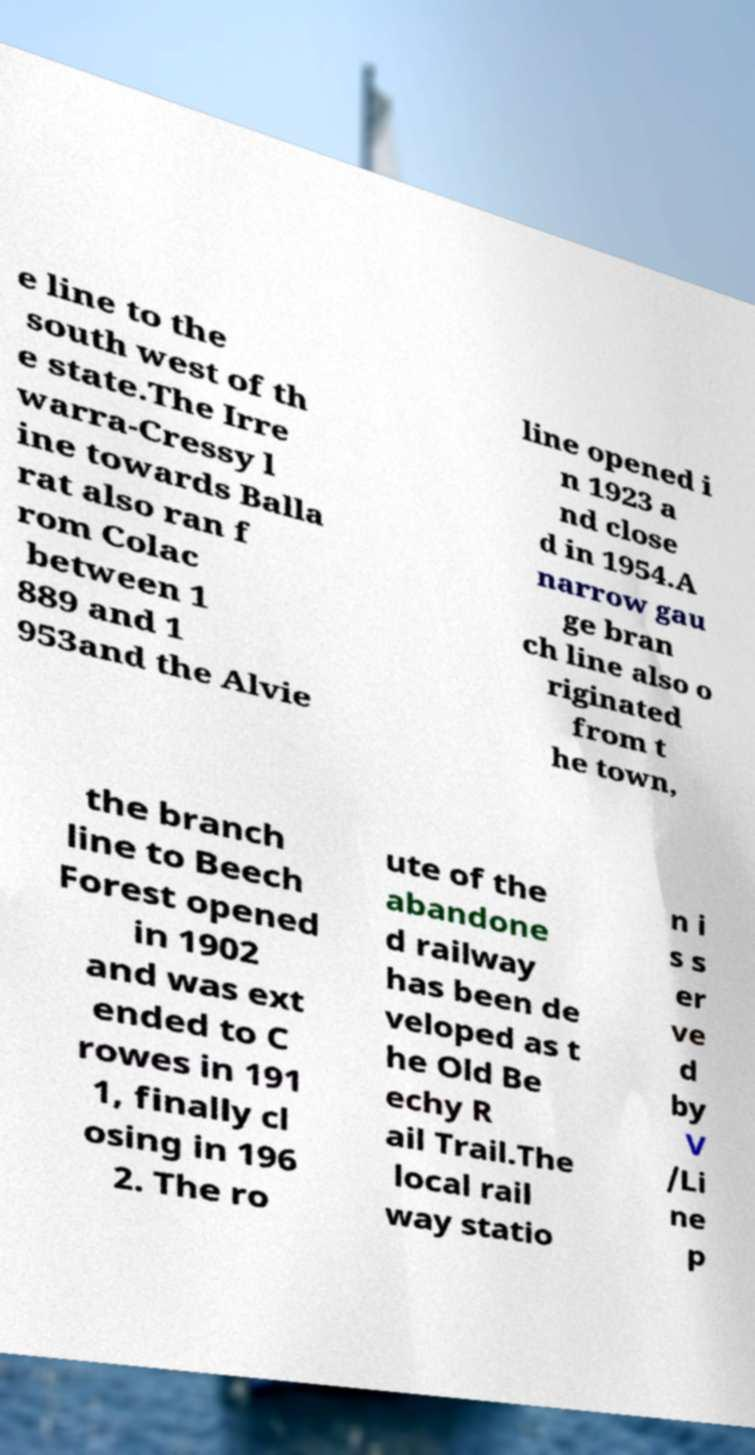What messages or text are displayed in this image? I need them in a readable, typed format. e line to the south west of th e state.The Irre warra-Cressy l ine towards Balla rat also ran f rom Colac between 1 889 and 1 953and the Alvie line opened i n 1923 a nd close d in 1954.A narrow gau ge bran ch line also o riginated from t he town, the branch line to Beech Forest opened in 1902 and was ext ended to C rowes in 191 1, finally cl osing in 196 2. The ro ute of the abandone d railway has been de veloped as t he Old Be echy R ail Trail.The local rail way statio n i s s er ve d by V /Li ne p 